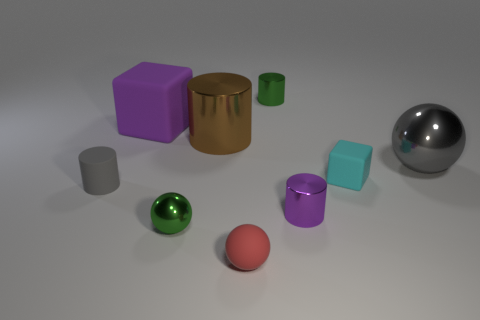What material is the green thing that is in front of the large metal thing in front of the large brown metallic object made of?
Offer a terse response. Metal. There is a brown cylinder; is its size the same as the metallic cylinder that is in front of the big gray ball?
Give a very brief answer. No. Is there a small metallic cylinder of the same color as the big matte object?
Ensure brevity in your answer.  Yes. What number of large objects are metal balls or cylinders?
Make the answer very short. 2. How many small gray matte cylinders are there?
Offer a very short reply. 1. There is a purple object behind the tiny cyan rubber object; what material is it?
Keep it short and to the point. Rubber. There is a red matte ball; are there any brown cylinders in front of it?
Keep it short and to the point. No. Is the size of the red rubber sphere the same as the brown object?
Your answer should be very brief. No. What number of large brown things are made of the same material as the small gray cylinder?
Make the answer very short. 0. There is a gray object on the right side of the green thing in front of the large gray metallic sphere; how big is it?
Provide a succinct answer. Large. 